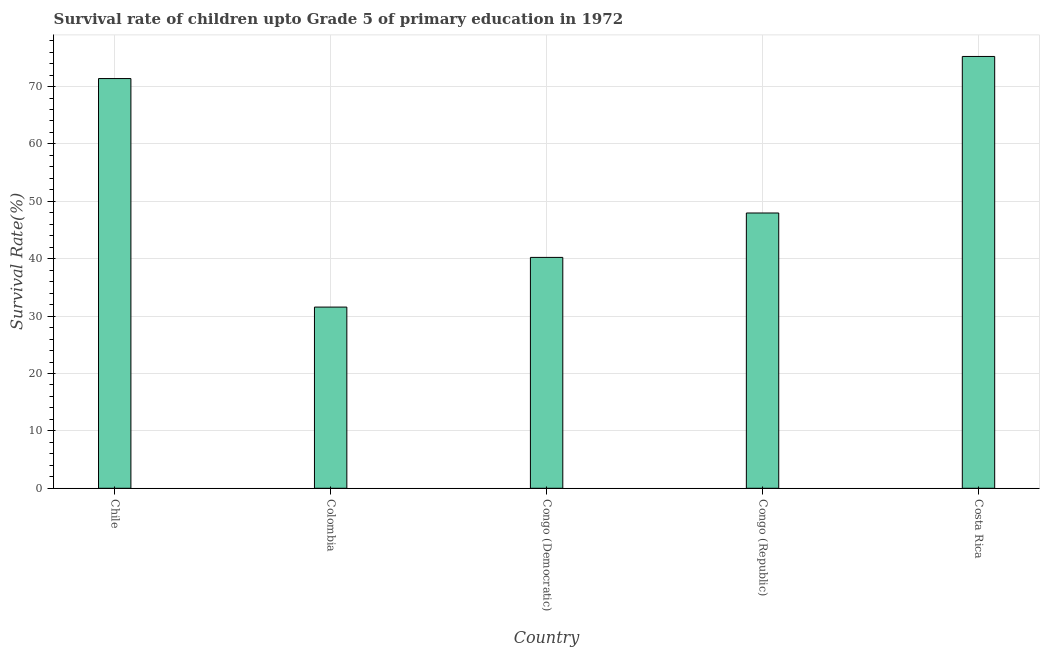Does the graph contain any zero values?
Provide a succinct answer. No. What is the title of the graph?
Offer a terse response. Survival rate of children upto Grade 5 of primary education in 1972 . What is the label or title of the Y-axis?
Ensure brevity in your answer.  Survival Rate(%). What is the survival rate in Congo (Democratic)?
Keep it short and to the point. 40.23. Across all countries, what is the maximum survival rate?
Keep it short and to the point. 75.24. Across all countries, what is the minimum survival rate?
Your answer should be compact. 31.57. In which country was the survival rate maximum?
Give a very brief answer. Costa Rica. In which country was the survival rate minimum?
Make the answer very short. Colombia. What is the sum of the survival rate?
Ensure brevity in your answer.  266.41. What is the difference between the survival rate in Colombia and Congo (Democratic)?
Provide a succinct answer. -8.66. What is the average survival rate per country?
Give a very brief answer. 53.28. What is the median survival rate?
Offer a very short reply. 47.97. What is the ratio of the survival rate in Chile to that in Colombia?
Ensure brevity in your answer.  2.26. Is the survival rate in Chile less than that in Congo (Republic)?
Make the answer very short. No. What is the difference between the highest and the second highest survival rate?
Offer a very short reply. 3.85. What is the difference between the highest and the lowest survival rate?
Provide a short and direct response. 43.67. How many bars are there?
Your response must be concise. 5. Are all the bars in the graph horizontal?
Keep it short and to the point. No. Are the values on the major ticks of Y-axis written in scientific E-notation?
Provide a short and direct response. No. What is the Survival Rate(%) in Chile?
Offer a very short reply. 71.39. What is the Survival Rate(%) in Colombia?
Provide a succinct answer. 31.57. What is the Survival Rate(%) in Congo (Democratic)?
Give a very brief answer. 40.23. What is the Survival Rate(%) of Congo (Republic)?
Give a very brief answer. 47.97. What is the Survival Rate(%) in Costa Rica?
Your answer should be compact. 75.24. What is the difference between the Survival Rate(%) in Chile and Colombia?
Your answer should be very brief. 39.82. What is the difference between the Survival Rate(%) in Chile and Congo (Democratic)?
Your answer should be compact. 31.16. What is the difference between the Survival Rate(%) in Chile and Congo (Republic)?
Provide a succinct answer. 23.43. What is the difference between the Survival Rate(%) in Chile and Costa Rica?
Make the answer very short. -3.85. What is the difference between the Survival Rate(%) in Colombia and Congo (Democratic)?
Offer a terse response. -8.66. What is the difference between the Survival Rate(%) in Colombia and Congo (Republic)?
Provide a short and direct response. -16.39. What is the difference between the Survival Rate(%) in Colombia and Costa Rica?
Your response must be concise. -43.67. What is the difference between the Survival Rate(%) in Congo (Democratic) and Congo (Republic)?
Provide a succinct answer. -7.74. What is the difference between the Survival Rate(%) in Congo (Democratic) and Costa Rica?
Your response must be concise. -35.01. What is the difference between the Survival Rate(%) in Congo (Republic) and Costa Rica?
Offer a very short reply. -27.27. What is the ratio of the Survival Rate(%) in Chile to that in Colombia?
Provide a succinct answer. 2.26. What is the ratio of the Survival Rate(%) in Chile to that in Congo (Democratic)?
Give a very brief answer. 1.77. What is the ratio of the Survival Rate(%) in Chile to that in Congo (Republic)?
Provide a succinct answer. 1.49. What is the ratio of the Survival Rate(%) in Chile to that in Costa Rica?
Ensure brevity in your answer.  0.95. What is the ratio of the Survival Rate(%) in Colombia to that in Congo (Democratic)?
Provide a succinct answer. 0.79. What is the ratio of the Survival Rate(%) in Colombia to that in Congo (Republic)?
Keep it short and to the point. 0.66. What is the ratio of the Survival Rate(%) in Colombia to that in Costa Rica?
Offer a very short reply. 0.42. What is the ratio of the Survival Rate(%) in Congo (Democratic) to that in Congo (Republic)?
Provide a succinct answer. 0.84. What is the ratio of the Survival Rate(%) in Congo (Democratic) to that in Costa Rica?
Give a very brief answer. 0.54. What is the ratio of the Survival Rate(%) in Congo (Republic) to that in Costa Rica?
Offer a very short reply. 0.64. 